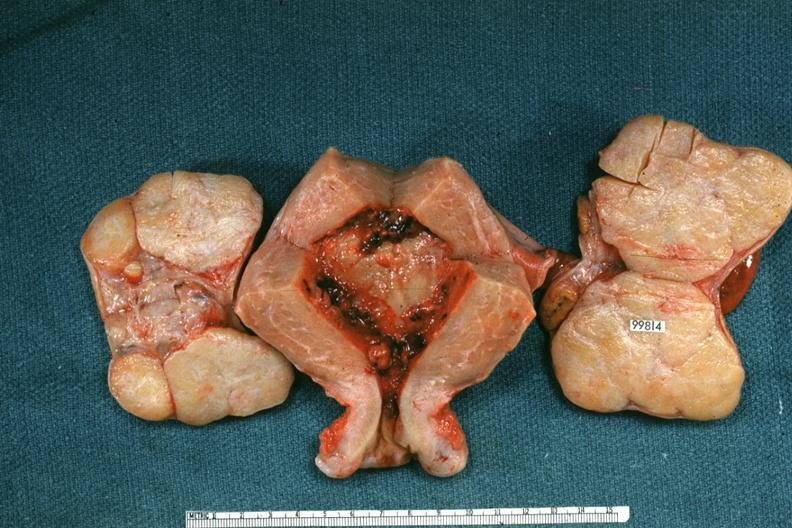where does this belong to?
Answer the question using a single word or phrase. Female reproductive system 